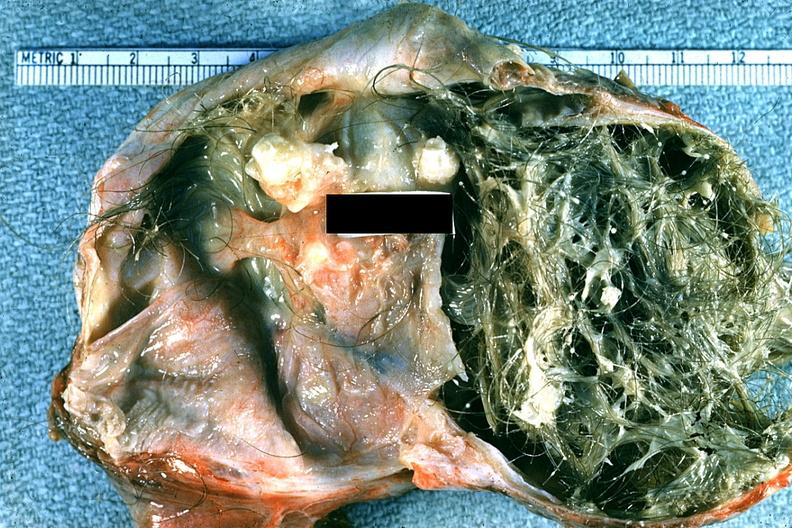what is present?
Answer the question using a single word or phrase. Ovary 